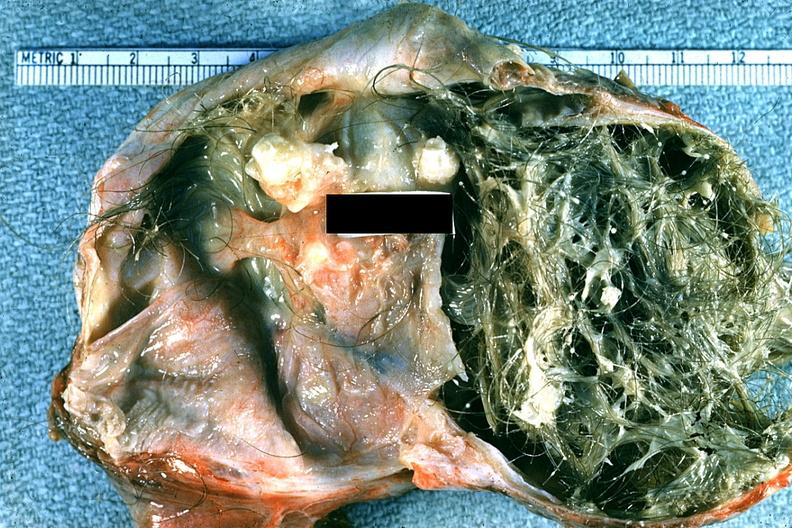what is present?
Answer the question using a single word or phrase. Ovary 